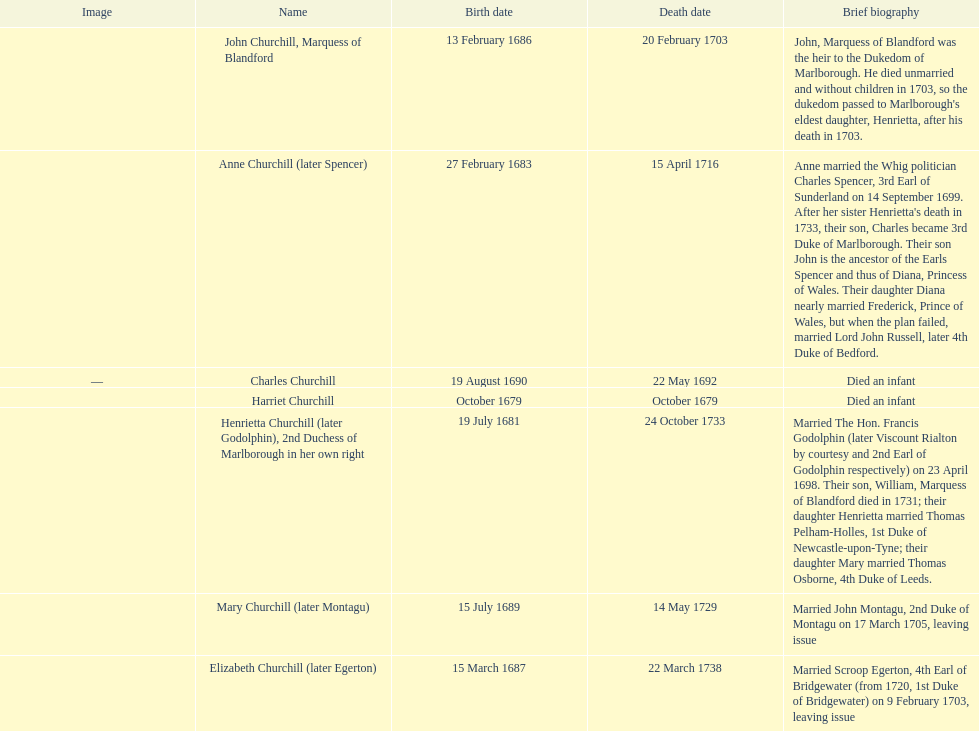What was the birthdate of sarah churchill's first child? October 1679. 